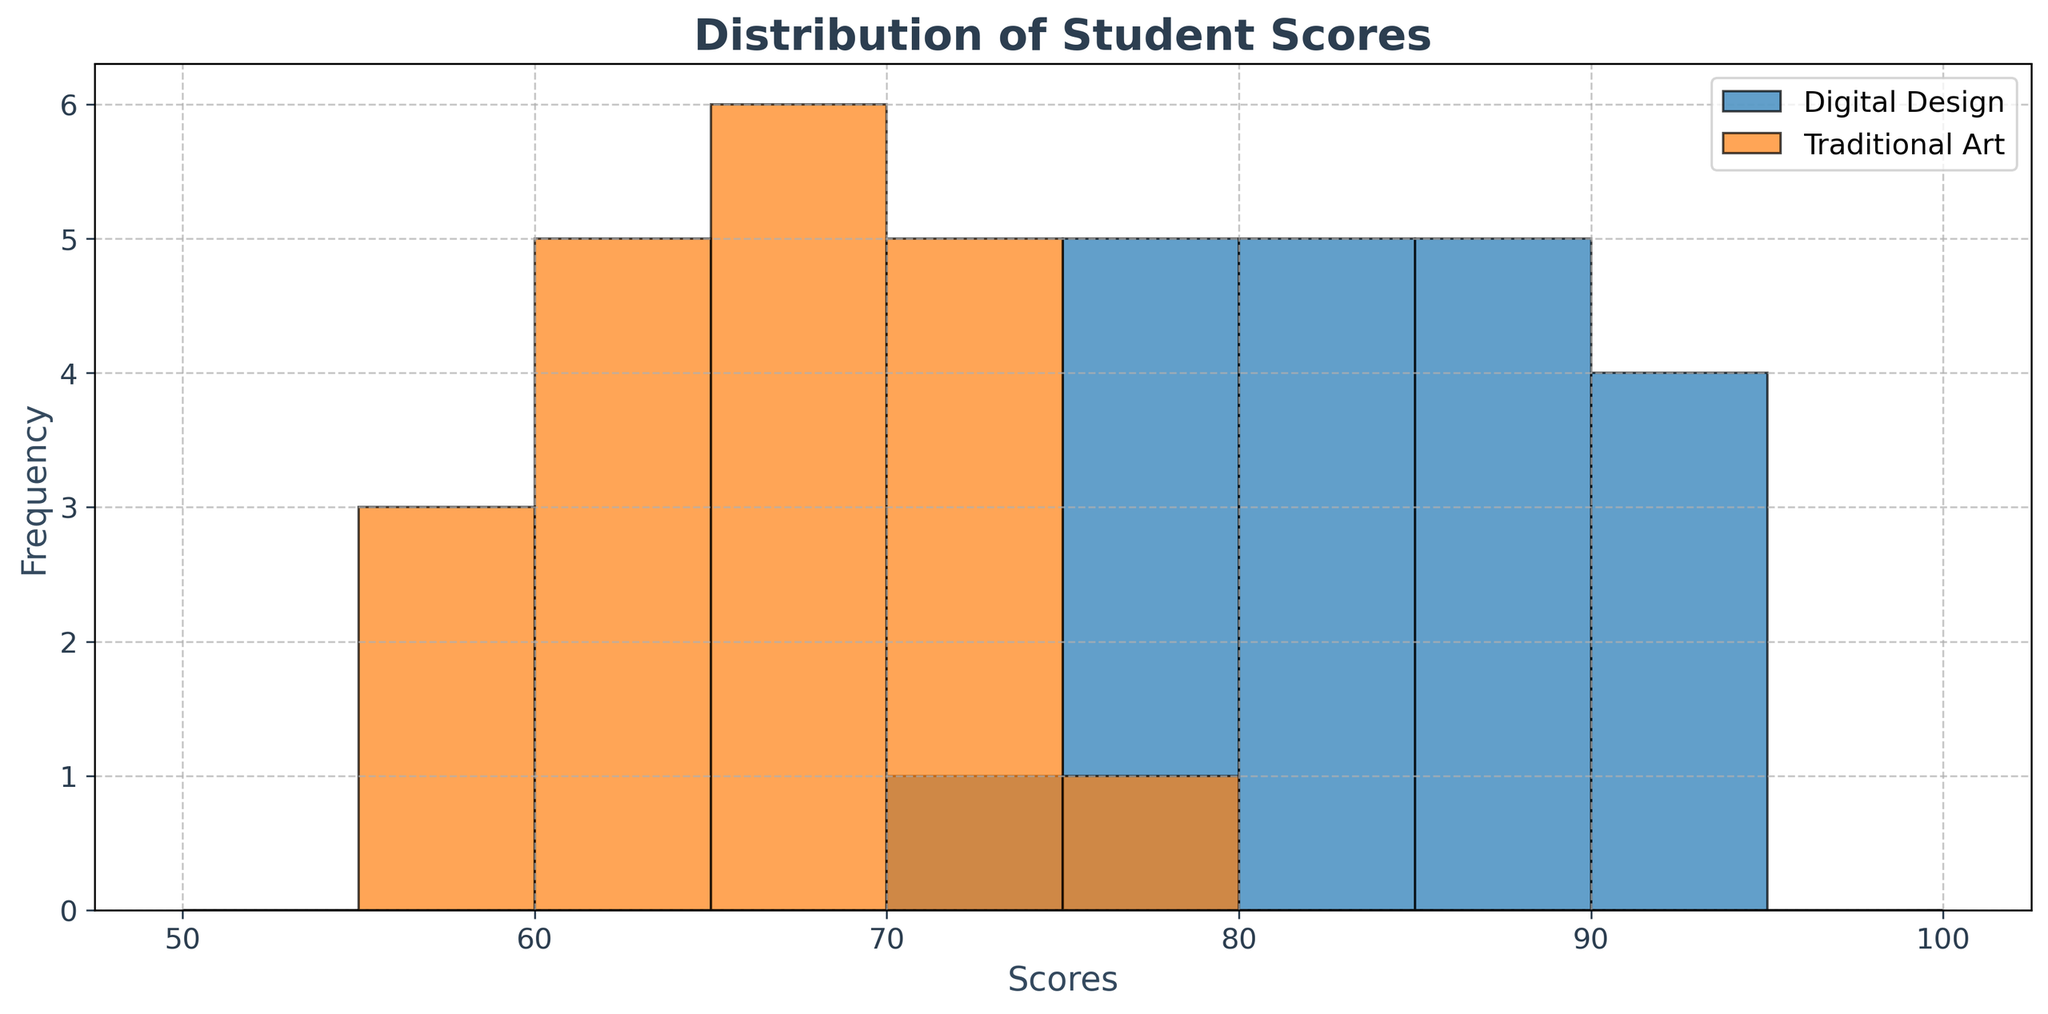What is the range of scores for Digital Design students? To find the range, we subtract the minimum score from the maximum score for Digital Design. The highest score is 93 and the lowest is 74. Thus, the range is 93 - 74.
Answer: 19 What is the mode of the Traditional Art scores? The mode is the score that appears most frequently. By looking at the histogram for Traditional Art, we can see that 70 and 66 both appear twice, making them the modes.
Answer: 70 and 66 Which course has the highest frequency of students scoring in the 80-85 range? We need to look at the height of the bars in the 80-85 range for both courses. The bar for Digital Design in this range is visibly higher than the corresponding bar for Traditional Art.
Answer: Digital Design Are there any scores that are more frequent in Traditional Art than in Digital Design? We compare the frequency of scores in each interval for Digital Design and Traditional Art. In the 55-60 range, Traditional Art has a higher frequency than Digital Design.
Answer: Yes, in the 55-60 range How many students scored between 85 and 90 in Digital Design? We count the number of students in the 85-90 bin. From the histogram, we see the bar height corresponding to this bin for Digital Design.
Answer: 3 What is the difference in the heights of the bars for the score range of 75-80 for Digital Design and Traditional Art? We subtract the height of the bar for Traditional Art in the 75-80 score range from the height of the bar for Digital Design in the same range. Digital Design has a higher bar here.
Answer: 1 Which course has the lowest score and what is it? By observing the lowest point on the x-axis where there is a bar for each course, we can identify the minimum score. For Traditional Art, the lowest score is 55.
Answer: Traditional Art; 55 How many more students scored between 70 and 75 in Traditional Art compared to Digital Design? We count the students in the 70-75 range for both courses and subtract the number for Digital Design from that for Traditional Art.
Answer: 2 Which score interval has zero students in Digital Design? We look for any bins within Digital Design's histogram that have a height of zero. The interval for 50-55 is empty.
Answer: 50-55 Is there a score range where both courses have the same frequency? We examine the histogram for bins where both courses have bars of equal height. Both courses have the same frequency in the 75-80 range.
Answer: 75-80 